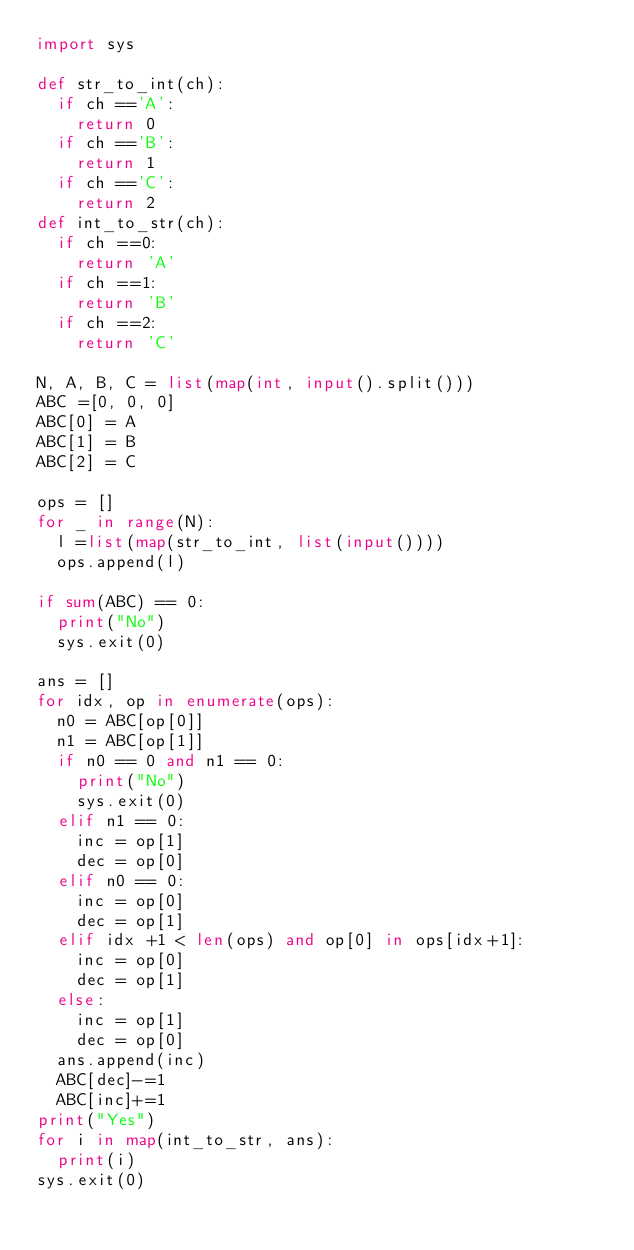<code> <loc_0><loc_0><loc_500><loc_500><_Python_>import sys

def str_to_int(ch):
	if ch =='A':
		return 0
	if ch =='B':
		return 1
	if ch =='C':
		return 2
def int_to_str(ch):
	if ch ==0:
		return 'A'
	if ch ==1:
		return 'B'
	if ch ==2:
		return 'C'

N, A, B, C = list(map(int, input().split()))
ABC =[0, 0, 0]
ABC[0] = A
ABC[1] = B
ABC[2] = C

ops = []
for _ in range(N):
	l =list(map(str_to_int, list(input())))
	ops.append(l)

if sum(ABC) == 0:
	print("No")
	sys.exit(0)

ans = []
for idx, op in enumerate(ops):
	n0 = ABC[op[0]]
	n1 = ABC[op[1]]
	if n0 == 0 and n1 == 0:
		print("No")
		sys.exit(0)
	elif n1 == 0:
		inc = op[1]
		dec = op[0]
	elif n0 == 0:
		inc = op[0]
		dec = op[1]
	elif idx +1 < len(ops) and op[0] in ops[idx+1]:
		inc = op[0]
		dec = op[1]
	else:
		inc = op[1]
		dec = op[0]
	ans.append(inc)
	ABC[dec]-=1
	ABC[inc]+=1
print("Yes")
for i in map(int_to_str, ans):
	print(i)
sys.exit(0)

</code> 